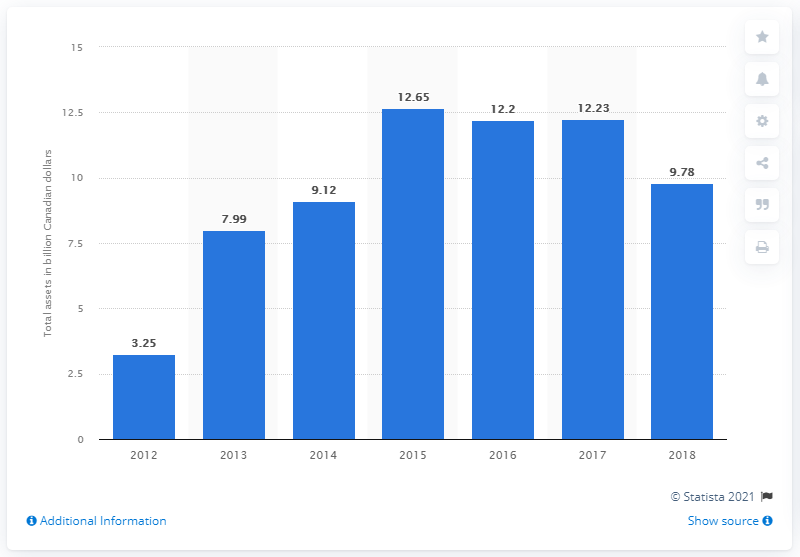Draw attention to some important aspects in this diagram. The total amount of Hudson's Bay Company's assets was 9.78.. 